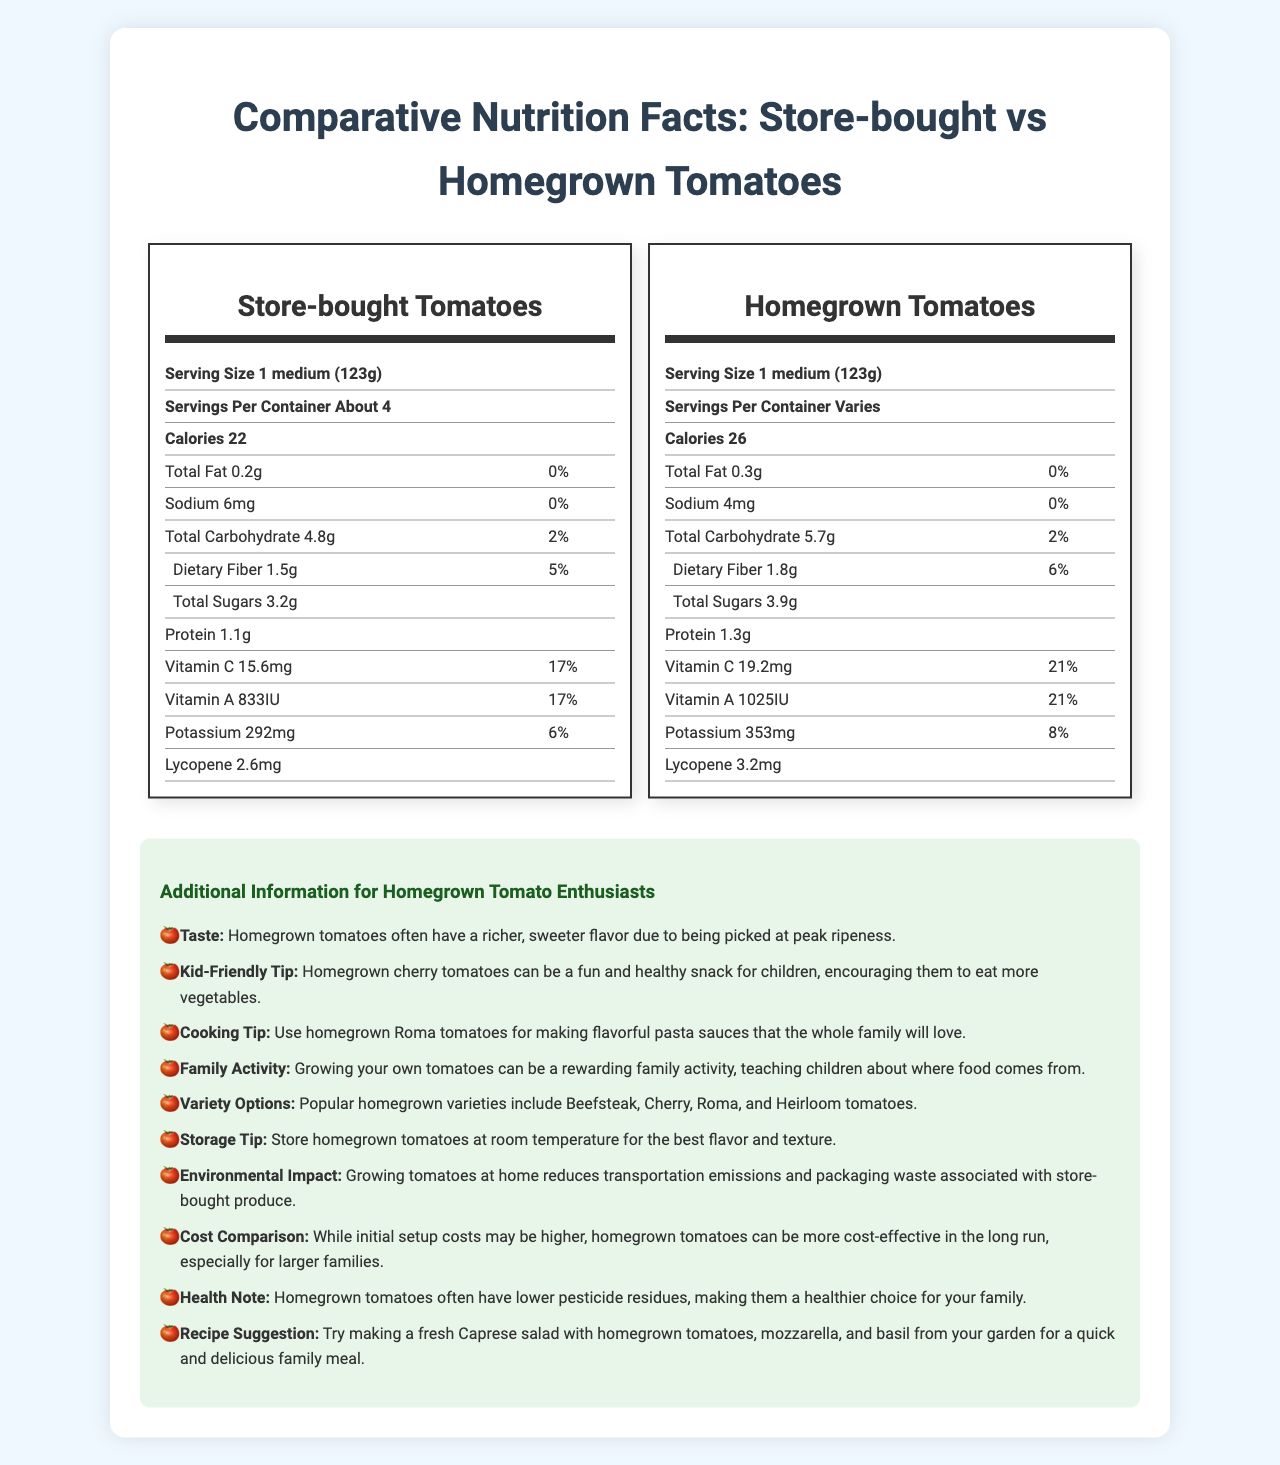what is the serving size of homegrown tomatoes? The serving size of homegrown tomatoes is listed as 1 medium (123g) in the nutrition facts table under homegrown tomatoes.
Answer: 1 medium (123g) how many calories are in one serving of store-bought tomatoes? The document mentions that store-bought tomatoes contain 22 calories per serving.
Answer: 22 calories what is the dietary fiber content in homegrown tomatoes? The nutrition facts label for homegrown tomatoes indicates that they contain 1.8g of dietary fiber.
Answer: 1.8g which type of tomato contains more potassium per serving? Homegrown tomatoes have 353mg of potassium per serving, compared to store-bought tomatoes which have 292mg.
Answer: Homegrown tomatoes what is the vitamin C daily value percentage for store-bought tomatoes? The vitamin C daily value percentage for store-bought tomatoes is 17%, as listed in the nutrition facts.
Answer: 17% what is the main difference in flavor between store-bought and homegrown tomatoes according to the document? The document states that homegrown tomatoes have a richer, sweeter flavor as they are picked at peak ripeness.
Answer: Homegrown tomatoes have a richer, sweeter flavor due to being picked at peak ripeness. For which cooking application are homegrown Roma tomatoes recommended? The additional information section suggests using homegrown Roma tomatoes for making flavorful pasta sauces.
Answer: Making flavorful pasta sauces how many grams of total sugars are in store-bought tomatoes? The nutrition label for store-bought tomatoes indicates they contain 3.2g of total sugars.
Answer: 3.2g compare the sodium content of store-bought and homegrown tomatoes. A. Store-bought: 6mg, Homegrown: 4mg B. Store-bought: 4mg, Homegrown: 6mg C. Store-bought: 10mg, Homegrown: 3mg Store-bought tomatoes contain 6mg of sodium, while homegrown tomatoes contain 4mg.
Answer: A. Store-bought: 6mg, Homegrown: 4mg which option is an environmental benefit of growing tomatoes at home? 1. Increases packaging waste 2. Reduces transportation emissions 3. Makes the soil infertile The document mentions that growing tomatoes at home reduces transportation emissions and packaging waste.
Answer: 2. Reduces transportation emissions are homegrown tomatoes more cost-effective for larger families in the long run? The document mentions that homegrown tomatoes can be more cost-effective in the long run, especially for larger families, despite initial setup costs.
Answer: Yes can you determine the exact cost-saving amount for growing tomatoes at home? The document mentions that growing tomatoes at home can be more cost-effective in the long run but does not provide specific cost-saving amounts.
Answer: Not enough information summarize the main idea of the document. The document compares the nutritional information of store-bought and homegrown tomatoes, emphasizing the superior nutritional content of homegrown tomatoes. It also provides various additional benefits like enhanced taste, cost-effectiveness, and minimal environmental impact, along with some practical tips and suggestions for home gardeners and cooking.
Answer: The document compares the nutrition facts of store-bought and homegrown tomatoes, highlighting that homegrown tomatoes generally have higher nutritional content. It also provides additional benefits of growing tomatoes at home, such as better taste, cost-effectiveness, and environmental advantages. 